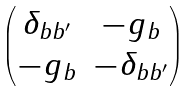<formula> <loc_0><loc_0><loc_500><loc_500>\begin{pmatrix} \delta _ { b b ^ { \prime } } & - g _ { b } \\ - g _ { b } & - \delta _ { b b ^ { \prime } } \end{pmatrix}</formula> 